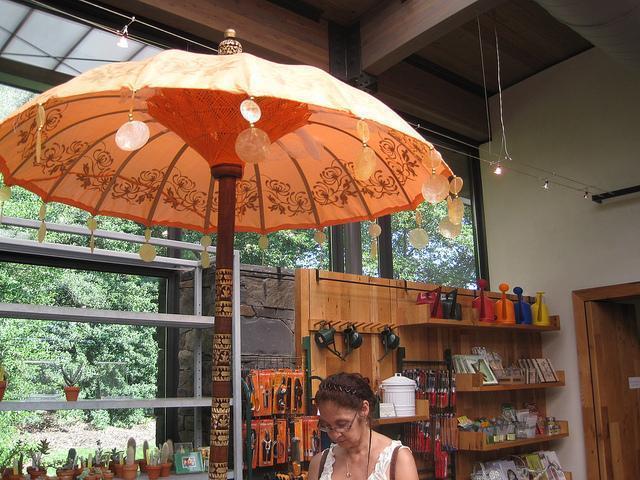What type of shop is this?
Choose the right answer from the provided options to respond to the question.
Options: Body, gift, hair, auto. Gift. 